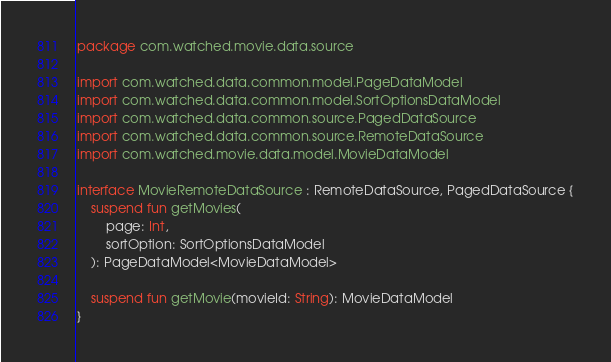Convert code to text. <code><loc_0><loc_0><loc_500><loc_500><_Kotlin_>package com.watched.movie.data.source

import com.watched.data.common.model.PageDataModel
import com.watched.data.common.model.SortOptionsDataModel
import com.watched.data.common.source.PagedDataSource
import com.watched.data.common.source.RemoteDataSource
import com.watched.movie.data.model.MovieDataModel

interface MovieRemoteDataSource : RemoteDataSource, PagedDataSource {
    suspend fun getMovies(
        page: Int,
        sortOption: SortOptionsDataModel
    ): PageDataModel<MovieDataModel>

    suspend fun getMovie(movieId: String): MovieDataModel
}
</code> 